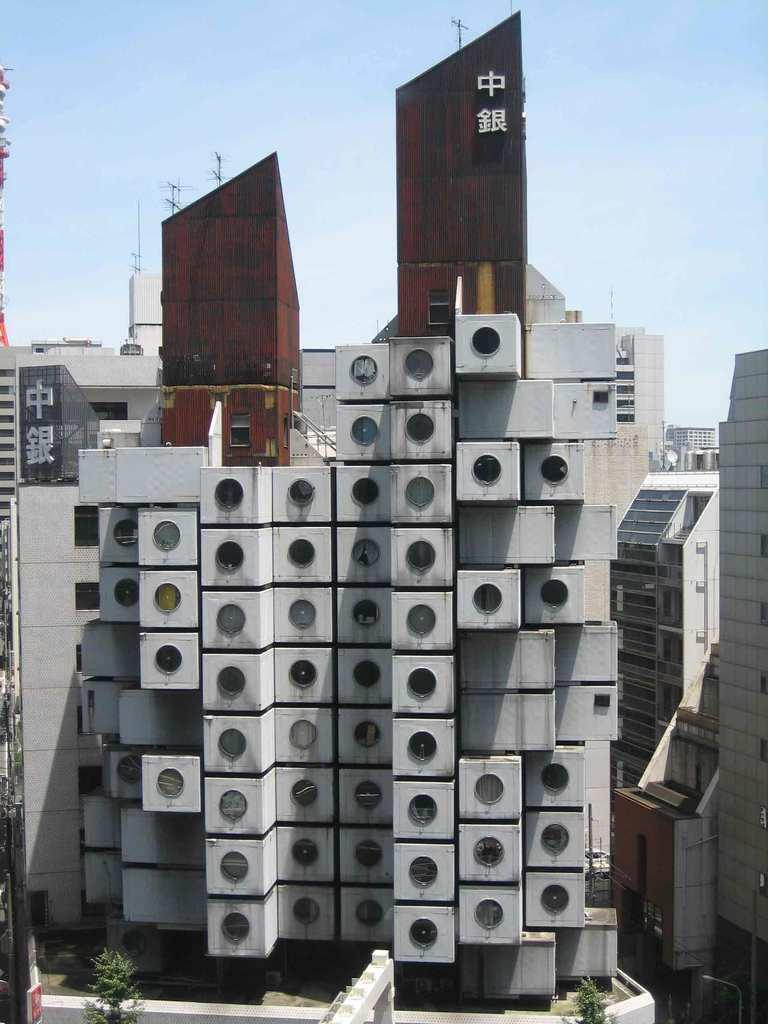Provide a one-sentence caption for the provided image. the outside of a building with chinese lettering at the top. 